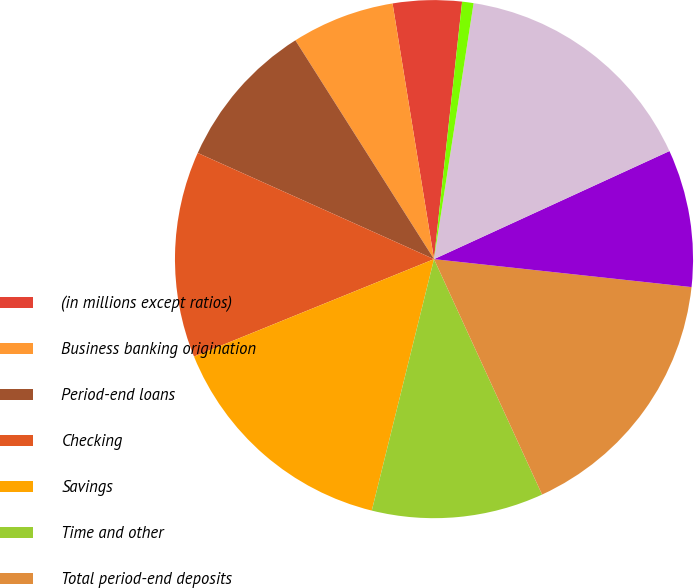Convert chart. <chart><loc_0><loc_0><loc_500><loc_500><pie_chart><fcel>(in millions except ratios)<fcel>Business banking origination<fcel>Period-end loans<fcel>Checking<fcel>Savings<fcel>Time and other<fcel>Total period-end deposits<fcel>Average loans<fcel>Total average deposits<fcel>Deposit margin<nl><fcel>4.29%<fcel>6.43%<fcel>9.29%<fcel>12.86%<fcel>15.0%<fcel>10.71%<fcel>16.43%<fcel>8.57%<fcel>15.71%<fcel>0.71%<nl></chart> 